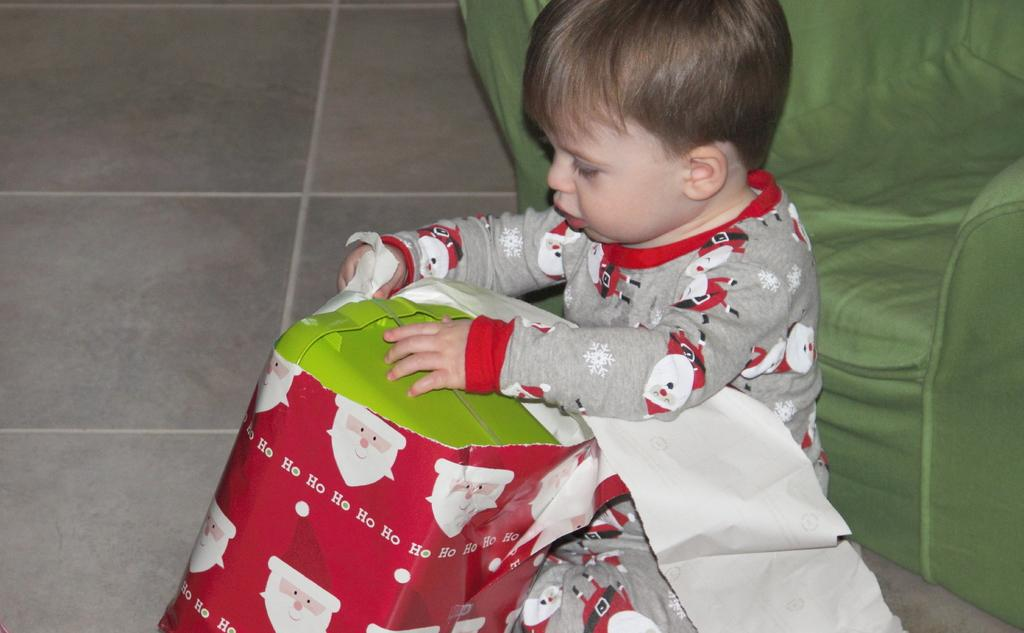What is the main subject of the image? The main subject of the image is a kid. What is the kid wearing? The kid is wearing clothes. What is the kid holding in the image? The kid is holding a box. What piece of furniture can be seen on the right side of the image? There is a sofa on the right side of the image. What type of mist can be seen surrounding the kid in the image? There is no mist present in the image; it is a clear scene with the kid, clothes, box, and sofa. 